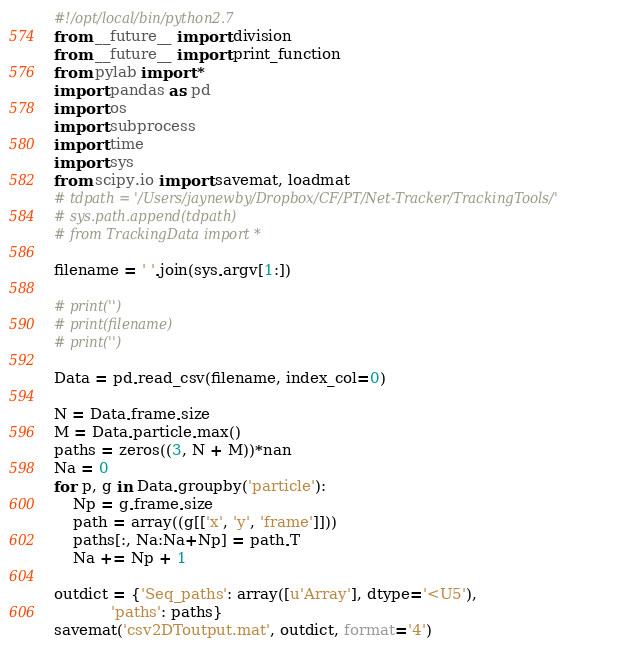<code> <loc_0><loc_0><loc_500><loc_500><_Python_>#!/opt/local/bin/python2.7
from __future__ import division
from __future__ import print_function
from pylab import *
import pandas as pd
import os
import subprocess
import time
import sys
from scipy.io import savemat, loadmat
# tdpath = '/Users/jaynewby/Dropbox/CF/PT/Net-Tracker/TrackingTools/'
# sys.path.append(tdpath)
# from TrackingData import *

filename = ' '.join(sys.argv[1:])

# print('')
# print(filename)
# print('')

Data = pd.read_csv(filename, index_col=0)

N = Data.frame.size
M = Data.particle.max()
paths = zeros((3, N + M))*nan
Na = 0
for p, g in Data.groupby('particle'):
    Np = g.frame.size
    path = array((g[['x', 'y', 'frame']]))
    paths[:, Na:Na+Np] = path.T
    Na += Np + 1

outdict = {'Seq_paths': array([u'Array'], dtype='<U5'),
            'paths': paths}
savemat('csv2DToutput.mat', outdict, format='4')
</code> 